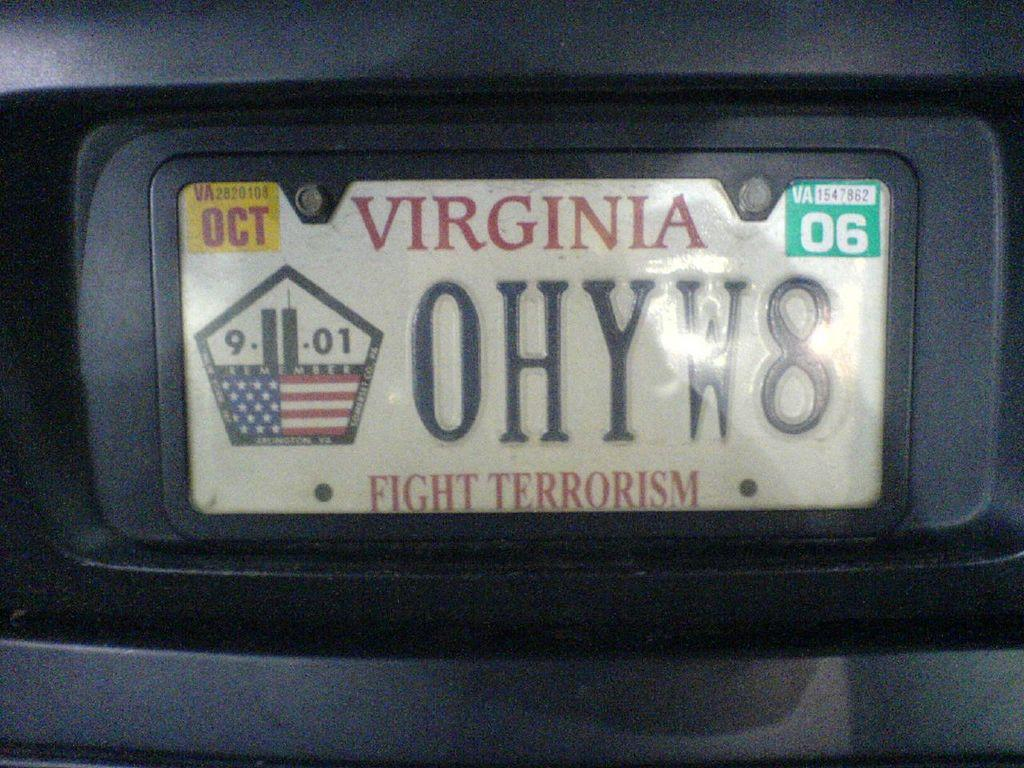What is the main object in the image? There is a white color board in the image. What is written on the board in red color? The word "VIRGINIA" is printed in red color on the board. What other text can be seen on the board? The text "OHYW8 FIGHT Terrorism" is printed on the board. What type of ice is being served at the airport in the image? There is no airport or ice present in the image; it only features a white color board with text. 